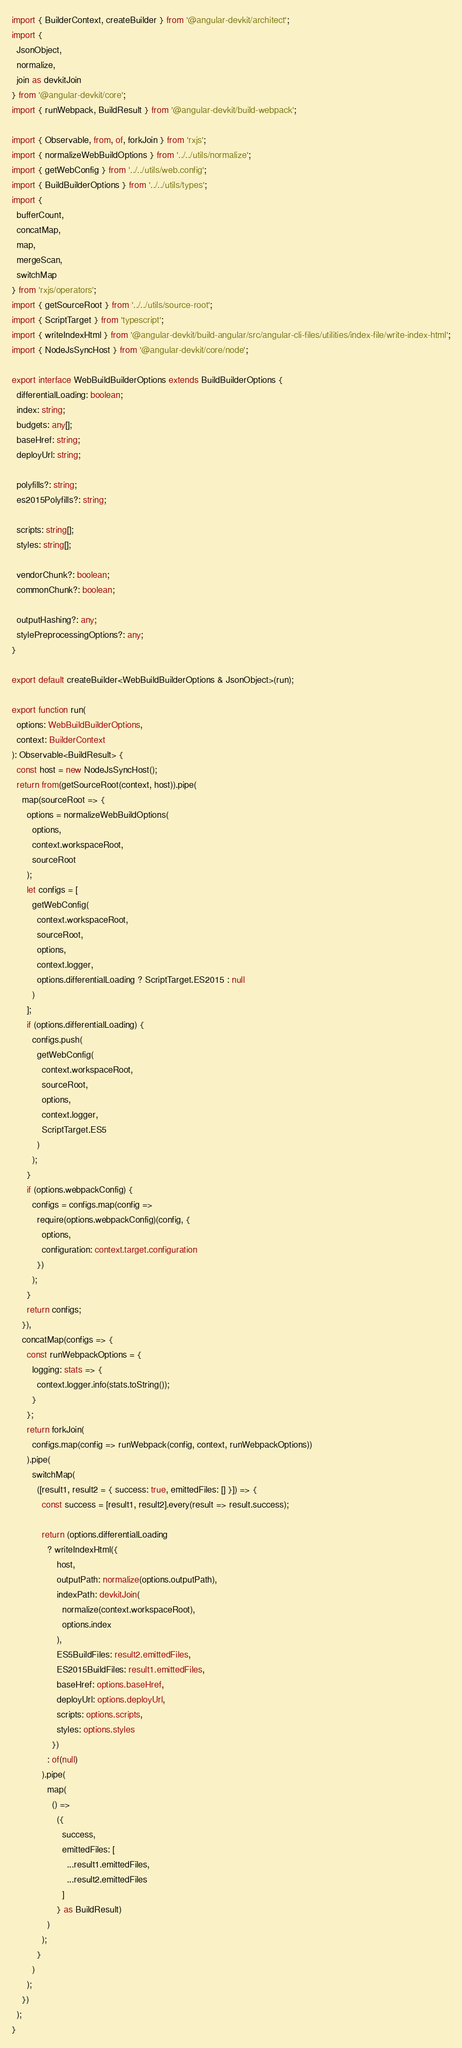<code> <loc_0><loc_0><loc_500><loc_500><_TypeScript_>import { BuilderContext, createBuilder } from '@angular-devkit/architect';
import {
  JsonObject,
  normalize,
  join as devkitJoin
} from '@angular-devkit/core';
import { runWebpack, BuildResult } from '@angular-devkit/build-webpack';

import { Observable, from, of, forkJoin } from 'rxjs';
import { normalizeWebBuildOptions } from '../../utils/normalize';
import { getWebConfig } from '../../utils/web.config';
import { BuildBuilderOptions } from '../../utils/types';
import {
  bufferCount,
  concatMap,
  map,
  mergeScan,
  switchMap
} from 'rxjs/operators';
import { getSourceRoot } from '../../utils/source-root';
import { ScriptTarget } from 'typescript';
import { writeIndexHtml } from '@angular-devkit/build-angular/src/angular-cli-files/utilities/index-file/write-index-html';
import { NodeJsSyncHost } from '@angular-devkit/core/node';

export interface WebBuildBuilderOptions extends BuildBuilderOptions {
  differentialLoading: boolean;
  index: string;
  budgets: any[];
  baseHref: string;
  deployUrl: string;

  polyfills?: string;
  es2015Polyfills?: string;

  scripts: string[];
  styles: string[];

  vendorChunk?: boolean;
  commonChunk?: boolean;

  outputHashing?: any;
  stylePreprocessingOptions?: any;
}

export default createBuilder<WebBuildBuilderOptions & JsonObject>(run);

export function run(
  options: WebBuildBuilderOptions,
  context: BuilderContext
): Observable<BuildResult> {
  const host = new NodeJsSyncHost();
  return from(getSourceRoot(context, host)).pipe(
    map(sourceRoot => {
      options = normalizeWebBuildOptions(
        options,
        context.workspaceRoot,
        sourceRoot
      );
      let configs = [
        getWebConfig(
          context.workspaceRoot,
          sourceRoot,
          options,
          context.logger,
          options.differentialLoading ? ScriptTarget.ES2015 : null
        )
      ];
      if (options.differentialLoading) {
        configs.push(
          getWebConfig(
            context.workspaceRoot,
            sourceRoot,
            options,
            context.logger,
            ScriptTarget.ES5
          )
        );
      }
      if (options.webpackConfig) {
        configs = configs.map(config =>
          require(options.webpackConfig)(config, {
            options,
            configuration: context.target.configuration
          })
        );
      }
      return configs;
    }),
    concatMap(configs => {
      const runWebpackOptions = {
        logging: stats => {
          context.logger.info(stats.toString());
        }
      };
      return forkJoin(
        configs.map(config => runWebpack(config, context, runWebpackOptions))
      ).pipe(
        switchMap(
          ([result1, result2 = { success: true, emittedFiles: [] }]) => {
            const success = [result1, result2].every(result => result.success);

            return (options.differentialLoading
              ? writeIndexHtml({
                  host,
                  outputPath: normalize(options.outputPath),
                  indexPath: devkitJoin(
                    normalize(context.workspaceRoot),
                    options.index
                  ),
                  ES5BuildFiles: result2.emittedFiles,
                  ES2015BuildFiles: result1.emittedFiles,
                  baseHref: options.baseHref,
                  deployUrl: options.deployUrl,
                  scripts: options.scripts,
                  styles: options.styles
                })
              : of(null)
            ).pipe(
              map(
                () =>
                  ({
                    success,
                    emittedFiles: [
                      ...result1.emittedFiles,
                      ...result2.emittedFiles
                    ]
                  } as BuildResult)
              )
            );
          }
        )
      );
    })
  );
}
</code> 